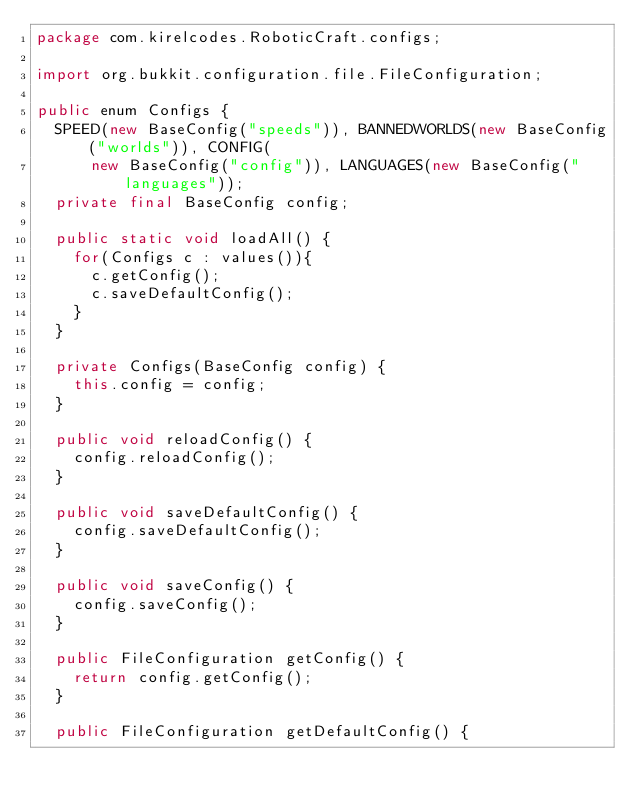Convert code to text. <code><loc_0><loc_0><loc_500><loc_500><_Java_>package com.kirelcodes.RoboticCraft.configs;

import org.bukkit.configuration.file.FileConfiguration;

public enum Configs {
	SPEED(new BaseConfig("speeds")), BANNEDWORLDS(new BaseConfig("worlds")), CONFIG(
			new BaseConfig("config")), LANGUAGES(new BaseConfig("languages"));
	private final BaseConfig config;

	public static void loadAll() {
		for(Configs c : values()){
			c.getConfig();
			c.saveDefaultConfig();
		}
	}

	private Configs(BaseConfig config) {
		this.config = config;
	}

	public void reloadConfig() {
		config.reloadConfig();
	}

	public void saveDefaultConfig() {
		config.saveDefaultConfig();
	}

	public void saveConfig() {
		config.saveConfig();
	}

	public FileConfiguration getConfig() {
		return config.getConfig();
	}

	public FileConfiguration getDefaultConfig() {</code> 